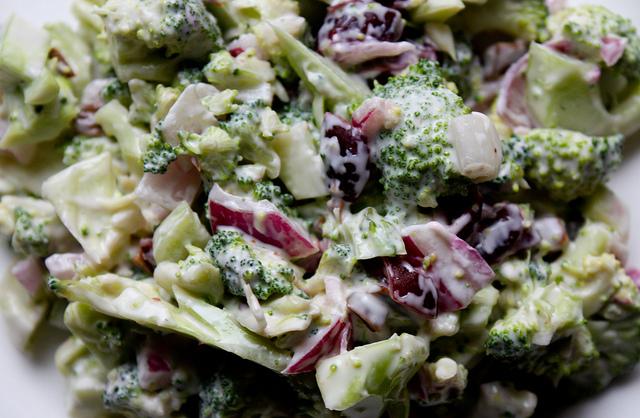What is the color of the salad?
Keep it brief. Green. Is there dressing on the salad?
Give a very brief answer. Yes. What type of salad is this?
Keep it brief. Broccoli. 